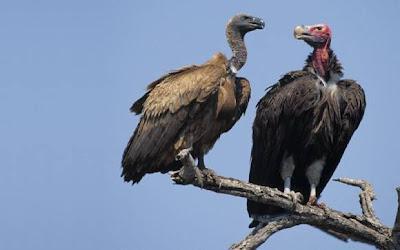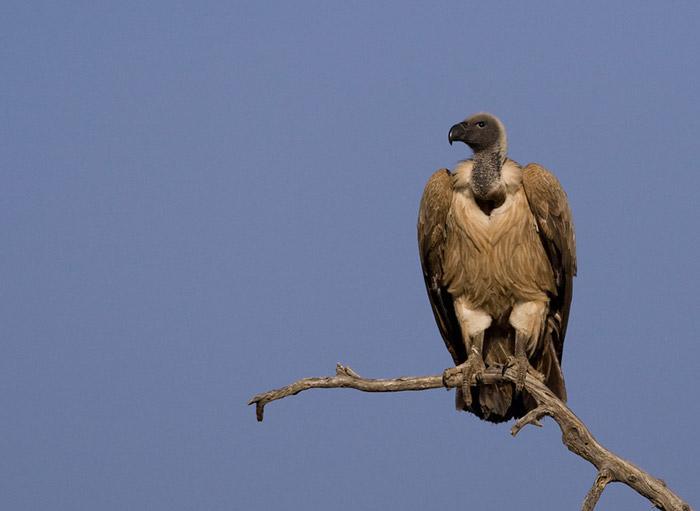The first image is the image on the left, the second image is the image on the right. Considering the images on both sides, is "There are three vultures" valid? Answer yes or no. Yes. 